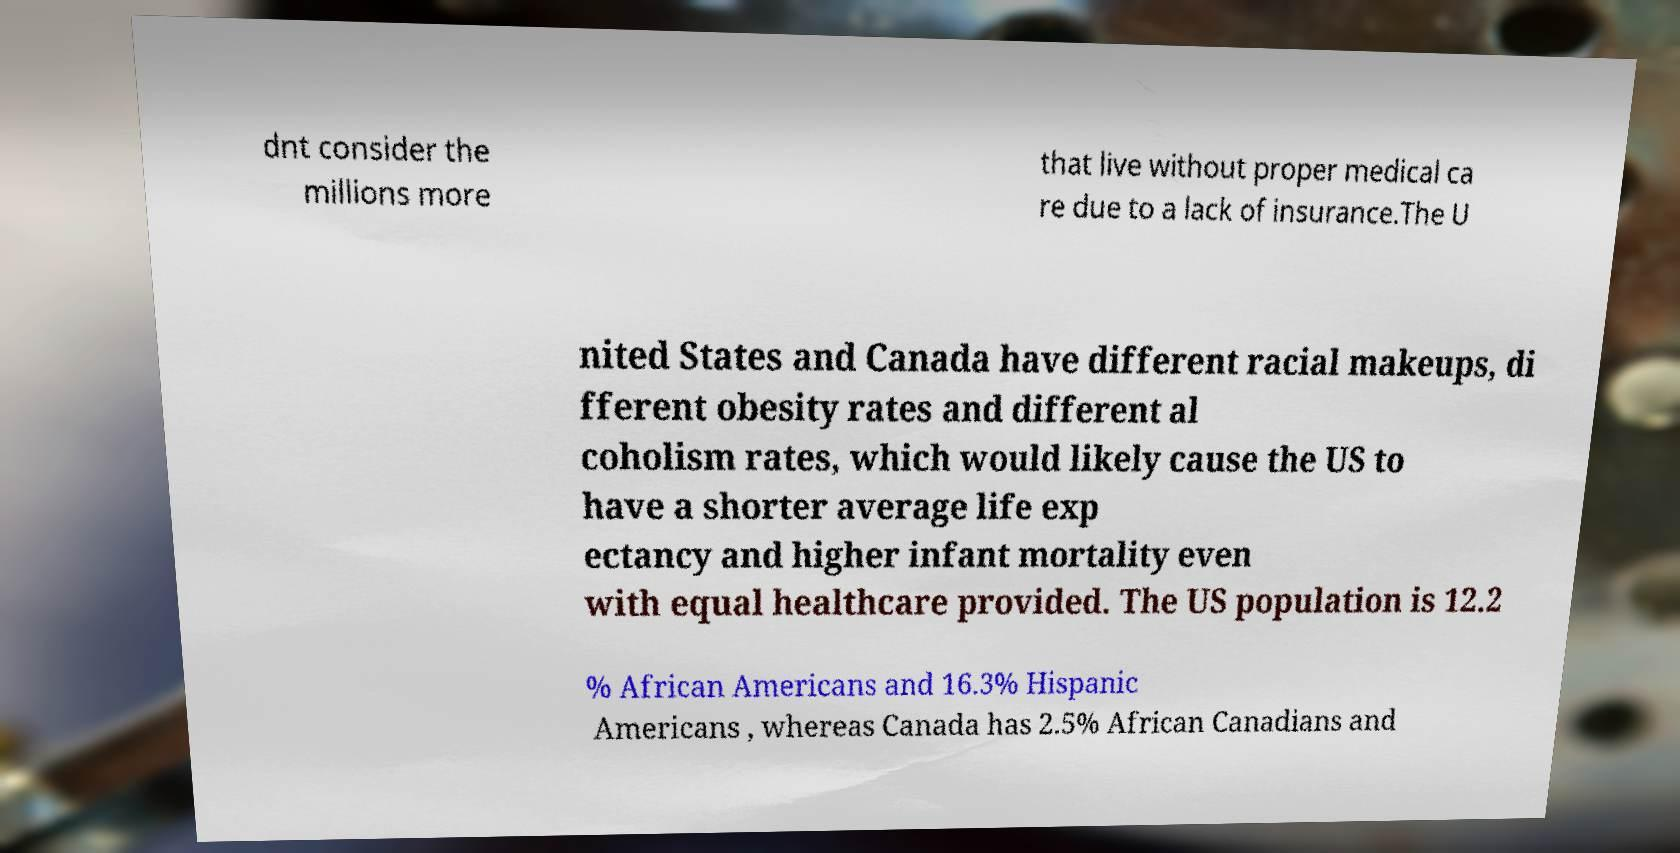Could you extract and type out the text from this image? dnt consider the millions more that live without proper medical ca re due to a lack of insurance.The U nited States and Canada have different racial makeups, di fferent obesity rates and different al coholism rates, which would likely cause the US to have a shorter average life exp ectancy and higher infant mortality even with equal healthcare provided. The US population is 12.2 % African Americans and 16.3% Hispanic Americans , whereas Canada has 2.5% African Canadians and 